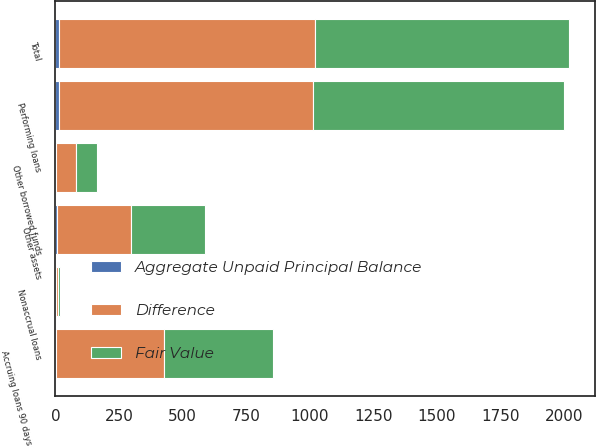<chart> <loc_0><loc_0><loc_500><loc_500><stacked_bar_chart><ecel><fcel>Performing loans<fcel>Total<fcel>Nonaccrual loans<fcel>Accruing loans 90 days or more<fcel>Other assets<fcel>Other borrowed funds<nl><fcel>Difference<fcel>1000<fcel>1010<fcel>5<fcel>427<fcel>293<fcel>81<nl><fcel>Fair Value<fcel>988<fcel>998<fcel>9<fcel>428<fcel>288<fcel>82<nl><fcel>Aggregate Unpaid Principal Balance<fcel>12<fcel>12<fcel>4<fcel>1<fcel>5<fcel>1<nl></chart> 